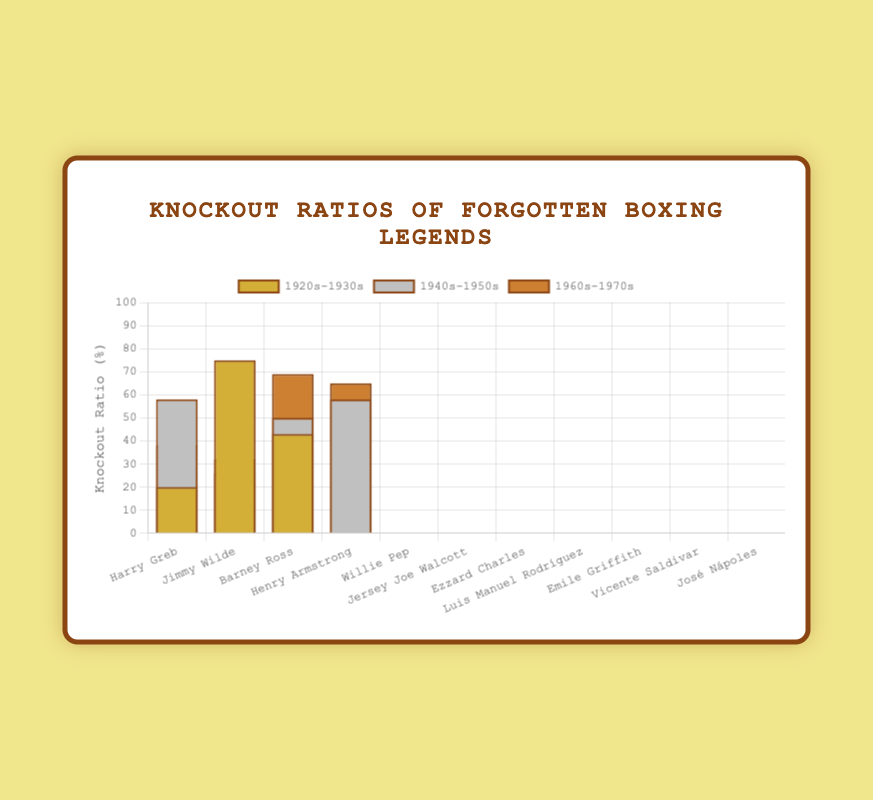Which boxer from the 1920s-1930s era has the highest knockout ratio? To find the boxer with the highest knockout ratio in the 1920s-1930s era, look at the knockout ratios associated with each boxer from that era. Jimmy Wilde has a knockout ratio of 75%, which is higher than Harry Greb (20%) and Barney Ross (43%).
Answer: Jimmy Wilde How does the average knockout ratio of the 1940s-1950s boxers compare to the 1960s-1970s boxers? Calculate the average knockout ratio for each era and then compare the two averages. The average knockout ratio for the 1940s-1950s is (58 + 26 + 50 + 58)/4 = 48%. For the 1960s-1970s, it's (38 + 32 + 69 + 65)/4 = 51%. Hence, the average knockout ratio of the 1960s-1970s boxers is higher.
Answer: The 1960s-1970s boxers have a higher average knockout ratio (51%) compared to the 1940s-1950s boxers (48%) Which boxers from the 1960s-1970s era have a knockout ratio greater than 50%? Check each boxer from the 1960s-1970s and identify those with a knockout ratio higher than 50%. Vicente Saldivar has 69% and José Nápoles has 65%, both are greater than 50%.
Answer: Vicente Saldivar and José Nápoles What is the total knockout ratio for all boxers in the 1920s-1930s? Sum the knockout ratios of all boxers from the 1920s-1930s era: 20 (Harry Greb) + 75 (Jimmy Wilde) + 43 (Barney Ross) = 138%.
Answer: 138% Which era has the boxer with the lowest knockout ratio, and who is that boxer? Identify the boxer with the lowest knockout ratio in each era and compare them. Harry Greb (20%) from the 1920s-1930s, Willie Pep (26%) from the 1940s-1950s, and Emile Griffith (32%) from the 1960s-1970s. Harry Greb, from the 1920s-1930s, has the lowest knockout ratio at 20%.
Answer: 1920s-1930s, Harry Greb List all the boxers with knockout ratios above 60% and identify their eras. Check the knockout ratios for all boxers and list those above 60%, along with their eras. Jimmy Wilde (1920s-1930s) with 75%, Vicente Saldivar (1960s-1970s) with 69%, and José Nápoles (1960s-1970s) with 65%.
Answer: Jimmy Wilde (1920s-1930s), Vicente Saldivar (1960s-1970s), José Nápoles (1960s-1970s) How many boxers from each era have a knockout ratio below 40%? Count the number of boxers in each era with a knockout ratio below 40%. For the 1920s-1930s: 1 (Harry Greb); for the 1940s-1950s: 1 (Willie Pep); for the 1960s-1970s: 2 (Luis Manuel Rodríguez, Emile Griffith).
Answer: 1920s-1930s: 1, 1940s-1950s: 1, 1960s-1970s: 2 What is the difference in knockout ratios between Harry Greb and Willie Pep? Subtract the knockout ratio of Harry Greb (20%) from Willie Pep (26%): 26% - 20% = 6%.
Answer: 6% In the era of the 1940s-1950s, who has the highest knockout ratio and how does it compare to the boxer with the lowest knockout ratio from the same era? Identify the boxer with the highest knockout ratio in the 1940s-1950s (Henry Armstrong and Ezzard Charles, both 58%) and compare it to the one with the lowest knockout ratio (Willie Pep, 26%). The difference is 58% - 26% = 32%.
Answer: Henry Armstrong/Ezzard Charles; 32% 